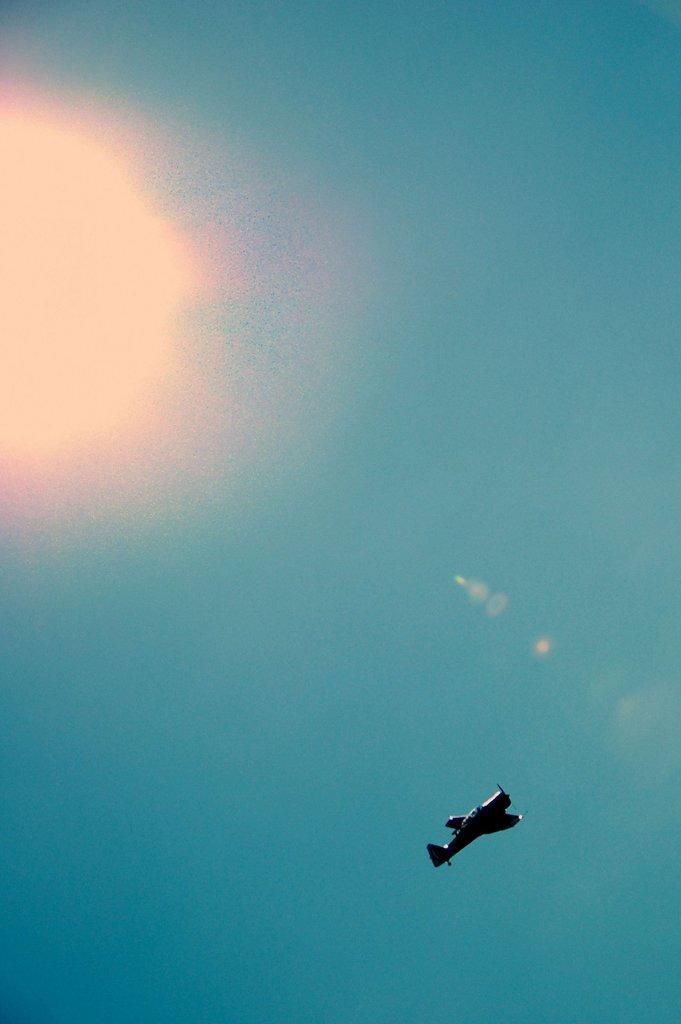What is the main subject of the image? The main subject of the image is an airplane. What is the airplane doing in the image? The airplane is flying in the image. What can be seen in the background of the image? The sky is visible in the background of the image. What type of haircut does the airplane have in the image? There is no haircut present in the image, as the subject is an airplane and not a person. 